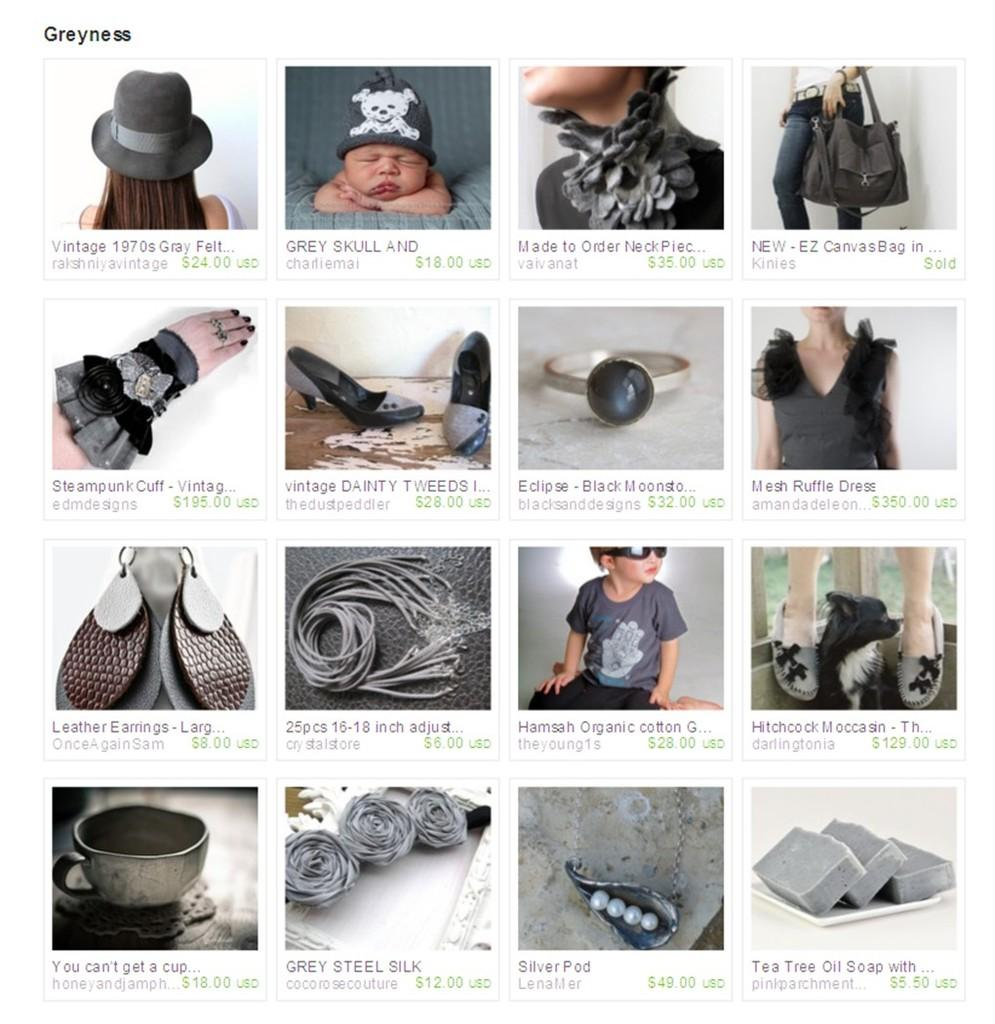What type of artwork is the image? The image is a collage. How many individual images are included in the collage? There are sixteen images in the collage. Is there any text present in the collage? Yes, there is text present in the collage. What type of haircut does the achiever have in the image? There is no achiever or haircut present in the image, as it is a collage of sixteen images with text. 